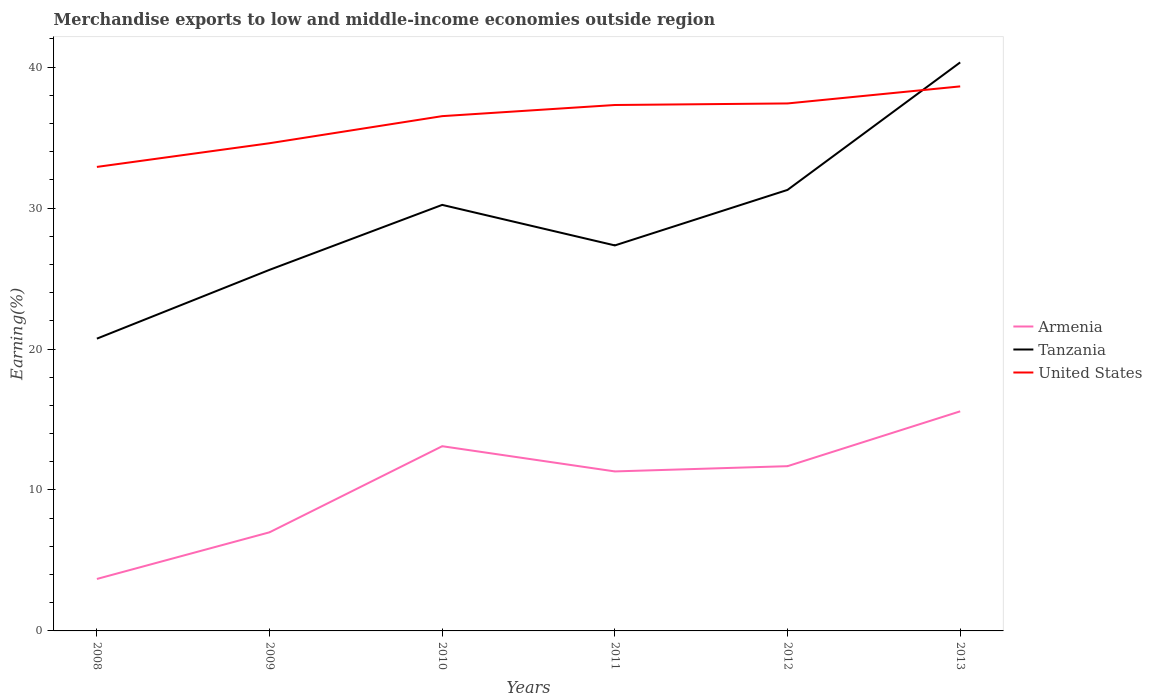How many different coloured lines are there?
Keep it short and to the point. 3. Does the line corresponding to Tanzania intersect with the line corresponding to United States?
Offer a terse response. Yes. Across all years, what is the maximum percentage of amount earned from merchandise exports in Armenia?
Provide a short and direct response. 3.69. In which year was the percentage of amount earned from merchandise exports in United States maximum?
Your answer should be compact. 2008. What is the total percentage of amount earned from merchandise exports in Tanzania in the graph?
Offer a terse response. -1.73. What is the difference between the highest and the second highest percentage of amount earned from merchandise exports in Armenia?
Your answer should be very brief. 11.89. Is the percentage of amount earned from merchandise exports in Armenia strictly greater than the percentage of amount earned from merchandise exports in United States over the years?
Give a very brief answer. Yes. How many lines are there?
Provide a succinct answer. 3. How many years are there in the graph?
Offer a very short reply. 6. What is the difference between two consecutive major ticks on the Y-axis?
Your answer should be very brief. 10. Are the values on the major ticks of Y-axis written in scientific E-notation?
Make the answer very short. No. Does the graph contain grids?
Make the answer very short. No. Where does the legend appear in the graph?
Provide a succinct answer. Center right. How many legend labels are there?
Offer a terse response. 3. How are the legend labels stacked?
Offer a very short reply. Vertical. What is the title of the graph?
Provide a succinct answer. Merchandise exports to low and middle-income economies outside region. What is the label or title of the Y-axis?
Offer a very short reply. Earning(%). What is the Earning(%) in Armenia in 2008?
Offer a terse response. 3.69. What is the Earning(%) of Tanzania in 2008?
Your response must be concise. 20.74. What is the Earning(%) in United States in 2008?
Your answer should be very brief. 32.92. What is the Earning(%) of Armenia in 2009?
Offer a very short reply. 7. What is the Earning(%) in Tanzania in 2009?
Offer a very short reply. 25.62. What is the Earning(%) of United States in 2009?
Keep it short and to the point. 34.6. What is the Earning(%) in Armenia in 2010?
Provide a short and direct response. 13.1. What is the Earning(%) in Tanzania in 2010?
Make the answer very short. 30.23. What is the Earning(%) in United States in 2010?
Your response must be concise. 36.52. What is the Earning(%) of Armenia in 2011?
Your response must be concise. 11.32. What is the Earning(%) of Tanzania in 2011?
Keep it short and to the point. 27.35. What is the Earning(%) of United States in 2011?
Your answer should be compact. 37.31. What is the Earning(%) in Armenia in 2012?
Offer a very short reply. 11.69. What is the Earning(%) of Tanzania in 2012?
Offer a terse response. 31.29. What is the Earning(%) in United States in 2012?
Your answer should be compact. 37.42. What is the Earning(%) of Armenia in 2013?
Your response must be concise. 15.58. What is the Earning(%) of Tanzania in 2013?
Provide a short and direct response. 40.33. What is the Earning(%) of United States in 2013?
Offer a terse response. 38.63. Across all years, what is the maximum Earning(%) in Armenia?
Give a very brief answer. 15.58. Across all years, what is the maximum Earning(%) in Tanzania?
Offer a very short reply. 40.33. Across all years, what is the maximum Earning(%) in United States?
Your response must be concise. 38.63. Across all years, what is the minimum Earning(%) of Armenia?
Provide a succinct answer. 3.69. Across all years, what is the minimum Earning(%) in Tanzania?
Ensure brevity in your answer.  20.74. Across all years, what is the minimum Earning(%) of United States?
Your answer should be compact. 32.92. What is the total Earning(%) of Armenia in the graph?
Offer a terse response. 62.37. What is the total Earning(%) of Tanzania in the graph?
Make the answer very short. 175.55. What is the total Earning(%) of United States in the graph?
Provide a short and direct response. 217.4. What is the difference between the Earning(%) in Armenia in 2008 and that in 2009?
Give a very brief answer. -3.31. What is the difference between the Earning(%) in Tanzania in 2008 and that in 2009?
Offer a terse response. -4.88. What is the difference between the Earning(%) in United States in 2008 and that in 2009?
Make the answer very short. -1.68. What is the difference between the Earning(%) in Armenia in 2008 and that in 2010?
Your answer should be very brief. -9.42. What is the difference between the Earning(%) of Tanzania in 2008 and that in 2010?
Your answer should be very brief. -9.49. What is the difference between the Earning(%) in United States in 2008 and that in 2010?
Your response must be concise. -3.6. What is the difference between the Earning(%) of Armenia in 2008 and that in 2011?
Ensure brevity in your answer.  -7.63. What is the difference between the Earning(%) of Tanzania in 2008 and that in 2011?
Your response must be concise. -6.61. What is the difference between the Earning(%) of United States in 2008 and that in 2011?
Keep it short and to the point. -4.39. What is the difference between the Earning(%) in Armenia in 2008 and that in 2012?
Your response must be concise. -8. What is the difference between the Earning(%) of Tanzania in 2008 and that in 2012?
Your answer should be very brief. -10.55. What is the difference between the Earning(%) of United States in 2008 and that in 2012?
Provide a succinct answer. -4.5. What is the difference between the Earning(%) of Armenia in 2008 and that in 2013?
Your answer should be compact. -11.89. What is the difference between the Earning(%) of Tanzania in 2008 and that in 2013?
Offer a terse response. -19.6. What is the difference between the Earning(%) of United States in 2008 and that in 2013?
Offer a terse response. -5.71. What is the difference between the Earning(%) in Armenia in 2009 and that in 2010?
Ensure brevity in your answer.  -6.11. What is the difference between the Earning(%) of Tanzania in 2009 and that in 2010?
Your response must be concise. -4.61. What is the difference between the Earning(%) in United States in 2009 and that in 2010?
Provide a short and direct response. -1.92. What is the difference between the Earning(%) in Armenia in 2009 and that in 2011?
Your answer should be compact. -4.32. What is the difference between the Earning(%) in Tanzania in 2009 and that in 2011?
Your response must be concise. -1.73. What is the difference between the Earning(%) in United States in 2009 and that in 2011?
Give a very brief answer. -2.71. What is the difference between the Earning(%) in Armenia in 2009 and that in 2012?
Your answer should be very brief. -4.69. What is the difference between the Earning(%) of Tanzania in 2009 and that in 2012?
Offer a very short reply. -5.67. What is the difference between the Earning(%) in United States in 2009 and that in 2012?
Make the answer very short. -2.82. What is the difference between the Earning(%) of Armenia in 2009 and that in 2013?
Your answer should be very brief. -8.58. What is the difference between the Earning(%) in Tanzania in 2009 and that in 2013?
Make the answer very short. -14.72. What is the difference between the Earning(%) in United States in 2009 and that in 2013?
Your answer should be very brief. -4.03. What is the difference between the Earning(%) in Armenia in 2010 and that in 2011?
Offer a very short reply. 1.79. What is the difference between the Earning(%) in Tanzania in 2010 and that in 2011?
Provide a short and direct response. 2.88. What is the difference between the Earning(%) of United States in 2010 and that in 2011?
Your answer should be very brief. -0.79. What is the difference between the Earning(%) of Armenia in 2010 and that in 2012?
Make the answer very short. 1.42. What is the difference between the Earning(%) in Tanzania in 2010 and that in 2012?
Make the answer very short. -1.06. What is the difference between the Earning(%) of United States in 2010 and that in 2012?
Offer a very short reply. -0.9. What is the difference between the Earning(%) of Armenia in 2010 and that in 2013?
Your response must be concise. -2.48. What is the difference between the Earning(%) of Tanzania in 2010 and that in 2013?
Your answer should be very brief. -10.11. What is the difference between the Earning(%) of United States in 2010 and that in 2013?
Provide a succinct answer. -2.11. What is the difference between the Earning(%) of Armenia in 2011 and that in 2012?
Your answer should be very brief. -0.37. What is the difference between the Earning(%) of Tanzania in 2011 and that in 2012?
Your answer should be compact. -3.94. What is the difference between the Earning(%) of United States in 2011 and that in 2012?
Keep it short and to the point. -0.11. What is the difference between the Earning(%) in Armenia in 2011 and that in 2013?
Your response must be concise. -4.26. What is the difference between the Earning(%) in Tanzania in 2011 and that in 2013?
Provide a succinct answer. -12.98. What is the difference between the Earning(%) in United States in 2011 and that in 2013?
Provide a short and direct response. -1.32. What is the difference between the Earning(%) in Armenia in 2012 and that in 2013?
Your answer should be very brief. -3.89. What is the difference between the Earning(%) of Tanzania in 2012 and that in 2013?
Offer a terse response. -9.05. What is the difference between the Earning(%) of United States in 2012 and that in 2013?
Offer a very short reply. -1.21. What is the difference between the Earning(%) in Armenia in 2008 and the Earning(%) in Tanzania in 2009?
Your answer should be compact. -21.93. What is the difference between the Earning(%) in Armenia in 2008 and the Earning(%) in United States in 2009?
Ensure brevity in your answer.  -30.91. What is the difference between the Earning(%) of Tanzania in 2008 and the Earning(%) of United States in 2009?
Your answer should be very brief. -13.86. What is the difference between the Earning(%) in Armenia in 2008 and the Earning(%) in Tanzania in 2010?
Give a very brief answer. -26.54. What is the difference between the Earning(%) in Armenia in 2008 and the Earning(%) in United States in 2010?
Your answer should be compact. -32.83. What is the difference between the Earning(%) in Tanzania in 2008 and the Earning(%) in United States in 2010?
Your response must be concise. -15.79. What is the difference between the Earning(%) in Armenia in 2008 and the Earning(%) in Tanzania in 2011?
Give a very brief answer. -23.66. What is the difference between the Earning(%) in Armenia in 2008 and the Earning(%) in United States in 2011?
Your answer should be compact. -33.62. What is the difference between the Earning(%) of Tanzania in 2008 and the Earning(%) of United States in 2011?
Make the answer very short. -16.58. What is the difference between the Earning(%) of Armenia in 2008 and the Earning(%) of Tanzania in 2012?
Offer a very short reply. -27.6. What is the difference between the Earning(%) in Armenia in 2008 and the Earning(%) in United States in 2012?
Offer a very short reply. -33.74. What is the difference between the Earning(%) in Tanzania in 2008 and the Earning(%) in United States in 2012?
Provide a succinct answer. -16.69. What is the difference between the Earning(%) in Armenia in 2008 and the Earning(%) in Tanzania in 2013?
Offer a terse response. -36.65. What is the difference between the Earning(%) in Armenia in 2008 and the Earning(%) in United States in 2013?
Offer a terse response. -34.94. What is the difference between the Earning(%) of Tanzania in 2008 and the Earning(%) of United States in 2013?
Give a very brief answer. -17.9. What is the difference between the Earning(%) of Armenia in 2009 and the Earning(%) of Tanzania in 2010?
Ensure brevity in your answer.  -23.23. What is the difference between the Earning(%) in Armenia in 2009 and the Earning(%) in United States in 2010?
Give a very brief answer. -29.52. What is the difference between the Earning(%) in Tanzania in 2009 and the Earning(%) in United States in 2010?
Your answer should be compact. -10.9. What is the difference between the Earning(%) of Armenia in 2009 and the Earning(%) of Tanzania in 2011?
Your answer should be very brief. -20.35. What is the difference between the Earning(%) in Armenia in 2009 and the Earning(%) in United States in 2011?
Your response must be concise. -30.31. What is the difference between the Earning(%) in Tanzania in 2009 and the Earning(%) in United States in 2011?
Give a very brief answer. -11.69. What is the difference between the Earning(%) in Armenia in 2009 and the Earning(%) in Tanzania in 2012?
Ensure brevity in your answer.  -24.29. What is the difference between the Earning(%) in Armenia in 2009 and the Earning(%) in United States in 2012?
Make the answer very short. -30.42. What is the difference between the Earning(%) in Tanzania in 2009 and the Earning(%) in United States in 2012?
Ensure brevity in your answer.  -11.8. What is the difference between the Earning(%) in Armenia in 2009 and the Earning(%) in Tanzania in 2013?
Make the answer very short. -33.34. What is the difference between the Earning(%) in Armenia in 2009 and the Earning(%) in United States in 2013?
Offer a terse response. -31.63. What is the difference between the Earning(%) in Tanzania in 2009 and the Earning(%) in United States in 2013?
Provide a succinct answer. -13.01. What is the difference between the Earning(%) in Armenia in 2010 and the Earning(%) in Tanzania in 2011?
Ensure brevity in your answer.  -14.25. What is the difference between the Earning(%) in Armenia in 2010 and the Earning(%) in United States in 2011?
Keep it short and to the point. -24.21. What is the difference between the Earning(%) of Tanzania in 2010 and the Earning(%) of United States in 2011?
Offer a terse response. -7.09. What is the difference between the Earning(%) of Armenia in 2010 and the Earning(%) of Tanzania in 2012?
Your answer should be very brief. -18.18. What is the difference between the Earning(%) of Armenia in 2010 and the Earning(%) of United States in 2012?
Ensure brevity in your answer.  -24.32. What is the difference between the Earning(%) of Tanzania in 2010 and the Earning(%) of United States in 2012?
Provide a succinct answer. -7.2. What is the difference between the Earning(%) in Armenia in 2010 and the Earning(%) in Tanzania in 2013?
Your answer should be compact. -27.23. What is the difference between the Earning(%) in Armenia in 2010 and the Earning(%) in United States in 2013?
Your answer should be very brief. -25.53. What is the difference between the Earning(%) in Tanzania in 2010 and the Earning(%) in United States in 2013?
Offer a terse response. -8.41. What is the difference between the Earning(%) in Armenia in 2011 and the Earning(%) in Tanzania in 2012?
Your response must be concise. -19.97. What is the difference between the Earning(%) of Armenia in 2011 and the Earning(%) of United States in 2012?
Your response must be concise. -26.11. What is the difference between the Earning(%) of Tanzania in 2011 and the Earning(%) of United States in 2012?
Keep it short and to the point. -10.07. What is the difference between the Earning(%) in Armenia in 2011 and the Earning(%) in Tanzania in 2013?
Ensure brevity in your answer.  -29.02. What is the difference between the Earning(%) of Armenia in 2011 and the Earning(%) of United States in 2013?
Ensure brevity in your answer.  -27.32. What is the difference between the Earning(%) of Tanzania in 2011 and the Earning(%) of United States in 2013?
Make the answer very short. -11.28. What is the difference between the Earning(%) in Armenia in 2012 and the Earning(%) in Tanzania in 2013?
Give a very brief answer. -28.65. What is the difference between the Earning(%) of Armenia in 2012 and the Earning(%) of United States in 2013?
Provide a short and direct response. -26.94. What is the difference between the Earning(%) of Tanzania in 2012 and the Earning(%) of United States in 2013?
Offer a terse response. -7.34. What is the average Earning(%) of Armenia per year?
Offer a very short reply. 10.39. What is the average Earning(%) in Tanzania per year?
Your answer should be compact. 29.26. What is the average Earning(%) of United States per year?
Offer a very short reply. 36.23. In the year 2008, what is the difference between the Earning(%) of Armenia and Earning(%) of Tanzania?
Provide a short and direct response. -17.05. In the year 2008, what is the difference between the Earning(%) of Armenia and Earning(%) of United States?
Ensure brevity in your answer.  -29.23. In the year 2008, what is the difference between the Earning(%) of Tanzania and Earning(%) of United States?
Provide a succinct answer. -12.18. In the year 2009, what is the difference between the Earning(%) in Armenia and Earning(%) in Tanzania?
Your answer should be compact. -18.62. In the year 2009, what is the difference between the Earning(%) of Armenia and Earning(%) of United States?
Ensure brevity in your answer.  -27.6. In the year 2009, what is the difference between the Earning(%) of Tanzania and Earning(%) of United States?
Offer a very short reply. -8.98. In the year 2010, what is the difference between the Earning(%) in Armenia and Earning(%) in Tanzania?
Your response must be concise. -17.12. In the year 2010, what is the difference between the Earning(%) in Armenia and Earning(%) in United States?
Offer a very short reply. -23.42. In the year 2010, what is the difference between the Earning(%) of Tanzania and Earning(%) of United States?
Your answer should be very brief. -6.3. In the year 2011, what is the difference between the Earning(%) in Armenia and Earning(%) in Tanzania?
Make the answer very short. -16.03. In the year 2011, what is the difference between the Earning(%) in Armenia and Earning(%) in United States?
Ensure brevity in your answer.  -26. In the year 2011, what is the difference between the Earning(%) in Tanzania and Earning(%) in United States?
Ensure brevity in your answer.  -9.96. In the year 2012, what is the difference between the Earning(%) in Armenia and Earning(%) in Tanzania?
Make the answer very short. -19.6. In the year 2012, what is the difference between the Earning(%) in Armenia and Earning(%) in United States?
Your answer should be very brief. -25.73. In the year 2012, what is the difference between the Earning(%) in Tanzania and Earning(%) in United States?
Your answer should be compact. -6.13. In the year 2013, what is the difference between the Earning(%) in Armenia and Earning(%) in Tanzania?
Make the answer very short. -24.75. In the year 2013, what is the difference between the Earning(%) in Armenia and Earning(%) in United States?
Provide a succinct answer. -23.05. In the year 2013, what is the difference between the Earning(%) of Tanzania and Earning(%) of United States?
Offer a very short reply. 1.7. What is the ratio of the Earning(%) in Armenia in 2008 to that in 2009?
Offer a terse response. 0.53. What is the ratio of the Earning(%) in Tanzania in 2008 to that in 2009?
Provide a short and direct response. 0.81. What is the ratio of the Earning(%) of United States in 2008 to that in 2009?
Ensure brevity in your answer.  0.95. What is the ratio of the Earning(%) of Armenia in 2008 to that in 2010?
Your answer should be very brief. 0.28. What is the ratio of the Earning(%) in Tanzania in 2008 to that in 2010?
Keep it short and to the point. 0.69. What is the ratio of the Earning(%) of United States in 2008 to that in 2010?
Offer a terse response. 0.9. What is the ratio of the Earning(%) in Armenia in 2008 to that in 2011?
Make the answer very short. 0.33. What is the ratio of the Earning(%) in Tanzania in 2008 to that in 2011?
Make the answer very short. 0.76. What is the ratio of the Earning(%) of United States in 2008 to that in 2011?
Your answer should be very brief. 0.88. What is the ratio of the Earning(%) in Armenia in 2008 to that in 2012?
Your answer should be very brief. 0.32. What is the ratio of the Earning(%) in Tanzania in 2008 to that in 2012?
Your answer should be compact. 0.66. What is the ratio of the Earning(%) in United States in 2008 to that in 2012?
Keep it short and to the point. 0.88. What is the ratio of the Earning(%) in Armenia in 2008 to that in 2013?
Keep it short and to the point. 0.24. What is the ratio of the Earning(%) in Tanzania in 2008 to that in 2013?
Offer a very short reply. 0.51. What is the ratio of the Earning(%) in United States in 2008 to that in 2013?
Offer a terse response. 0.85. What is the ratio of the Earning(%) in Armenia in 2009 to that in 2010?
Provide a succinct answer. 0.53. What is the ratio of the Earning(%) of Tanzania in 2009 to that in 2010?
Offer a very short reply. 0.85. What is the ratio of the Earning(%) in United States in 2009 to that in 2010?
Offer a terse response. 0.95. What is the ratio of the Earning(%) in Armenia in 2009 to that in 2011?
Your answer should be compact. 0.62. What is the ratio of the Earning(%) in Tanzania in 2009 to that in 2011?
Make the answer very short. 0.94. What is the ratio of the Earning(%) of United States in 2009 to that in 2011?
Provide a short and direct response. 0.93. What is the ratio of the Earning(%) of Armenia in 2009 to that in 2012?
Provide a short and direct response. 0.6. What is the ratio of the Earning(%) of Tanzania in 2009 to that in 2012?
Your answer should be very brief. 0.82. What is the ratio of the Earning(%) of United States in 2009 to that in 2012?
Make the answer very short. 0.92. What is the ratio of the Earning(%) in Armenia in 2009 to that in 2013?
Make the answer very short. 0.45. What is the ratio of the Earning(%) of Tanzania in 2009 to that in 2013?
Provide a succinct answer. 0.64. What is the ratio of the Earning(%) of United States in 2009 to that in 2013?
Make the answer very short. 0.9. What is the ratio of the Earning(%) of Armenia in 2010 to that in 2011?
Provide a short and direct response. 1.16. What is the ratio of the Earning(%) in Tanzania in 2010 to that in 2011?
Offer a very short reply. 1.11. What is the ratio of the Earning(%) of United States in 2010 to that in 2011?
Offer a terse response. 0.98. What is the ratio of the Earning(%) in Armenia in 2010 to that in 2012?
Your response must be concise. 1.12. What is the ratio of the Earning(%) in Tanzania in 2010 to that in 2012?
Ensure brevity in your answer.  0.97. What is the ratio of the Earning(%) in United States in 2010 to that in 2012?
Ensure brevity in your answer.  0.98. What is the ratio of the Earning(%) of Armenia in 2010 to that in 2013?
Keep it short and to the point. 0.84. What is the ratio of the Earning(%) of Tanzania in 2010 to that in 2013?
Your answer should be very brief. 0.75. What is the ratio of the Earning(%) in United States in 2010 to that in 2013?
Offer a terse response. 0.95. What is the ratio of the Earning(%) in Armenia in 2011 to that in 2012?
Offer a very short reply. 0.97. What is the ratio of the Earning(%) of Tanzania in 2011 to that in 2012?
Your answer should be very brief. 0.87. What is the ratio of the Earning(%) in Armenia in 2011 to that in 2013?
Keep it short and to the point. 0.73. What is the ratio of the Earning(%) of Tanzania in 2011 to that in 2013?
Offer a terse response. 0.68. What is the ratio of the Earning(%) of United States in 2011 to that in 2013?
Give a very brief answer. 0.97. What is the ratio of the Earning(%) in Armenia in 2012 to that in 2013?
Provide a succinct answer. 0.75. What is the ratio of the Earning(%) in Tanzania in 2012 to that in 2013?
Your answer should be very brief. 0.78. What is the ratio of the Earning(%) in United States in 2012 to that in 2013?
Provide a succinct answer. 0.97. What is the difference between the highest and the second highest Earning(%) in Armenia?
Make the answer very short. 2.48. What is the difference between the highest and the second highest Earning(%) in Tanzania?
Offer a terse response. 9.05. What is the difference between the highest and the second highest Earning(%) of United States?
Provide a short and direct response. 1.21. What is the difference between the highest and the lowest Earning(%) of Armenia?
Make the answer very short. 11.89. What is the difference between the highest and the lowest Earning(%) of Tanzania?
Your answer should be compact. 19.6. What is the difference between the highest and the lowest Earning(%) in United States?
Provide a short and direct response. 5.71. 